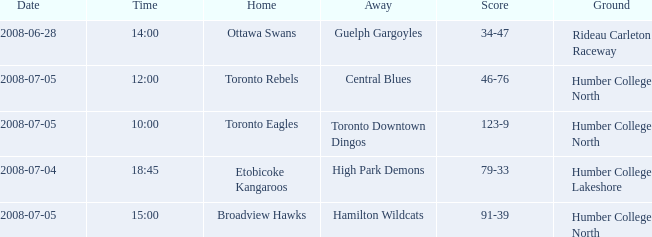What is the Away with a Time that is 14:00? Guelph Gargoyles. 